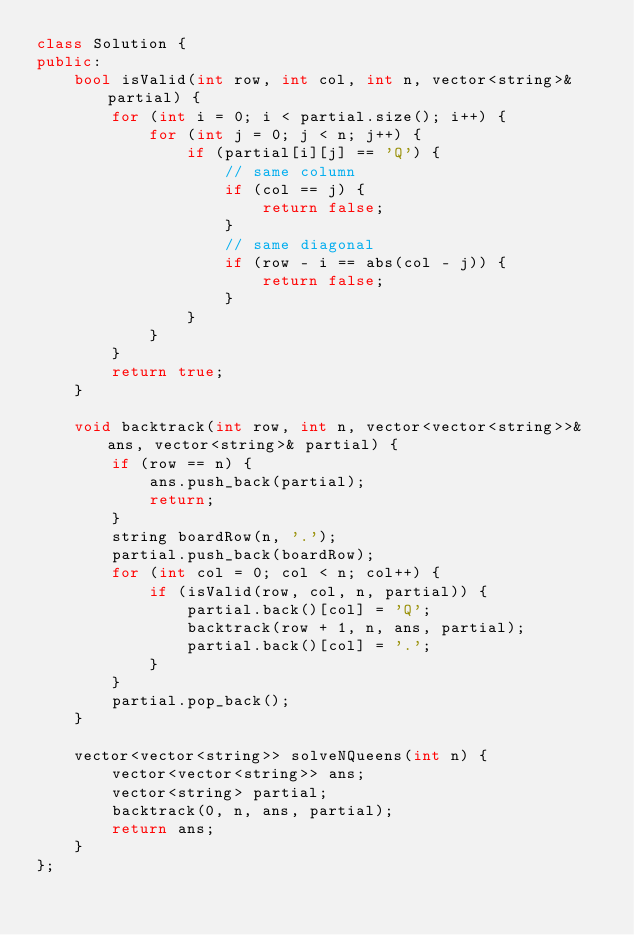<code> <loc_0><loc_0><loc_500><loc_500><_C++_>class Solution {
public:
    bool isValid(int row, int col, int n, vector<string>& partial) {
        for (int i = 0; i < partial.size(); i++) {
            for (int j = 0; j < n; j++) {
                if (partial[i][j] == 'Q') {
                    // same column
                    if (col == j) {
                        return false;
                    }
                    // same diagonal
                    if (row - i == abs(col - j)) {
                        return false;
                    }
                }
            }
        }
        return true;
    }
    
    void backtrack(int row, int n, vector<vector<string>>& ans, vector<string>& partial) {
        if (row == n) {
            ans.push_back(partial);
            return;
        }
        string boardRow(n, '.');
        partial.push_back(boardRow);
        for (int col = 0; col < n; col++) {
            if (isValid(row, col, n, partial)) {
                partial.back()[col] = 'Q';
                backtrack(row + 1, n, ans, partial);
                partial.back()[col] = '.';    
            }
        }
        partial.pop_back();
    }
    
    vector<vector<string>> solveNQueens(int n) {
        vector<vector<string>> ans;
        vector<string> partial;
        backtrack(0, n, ans, partial);
        return ans;
    }
};</code> 